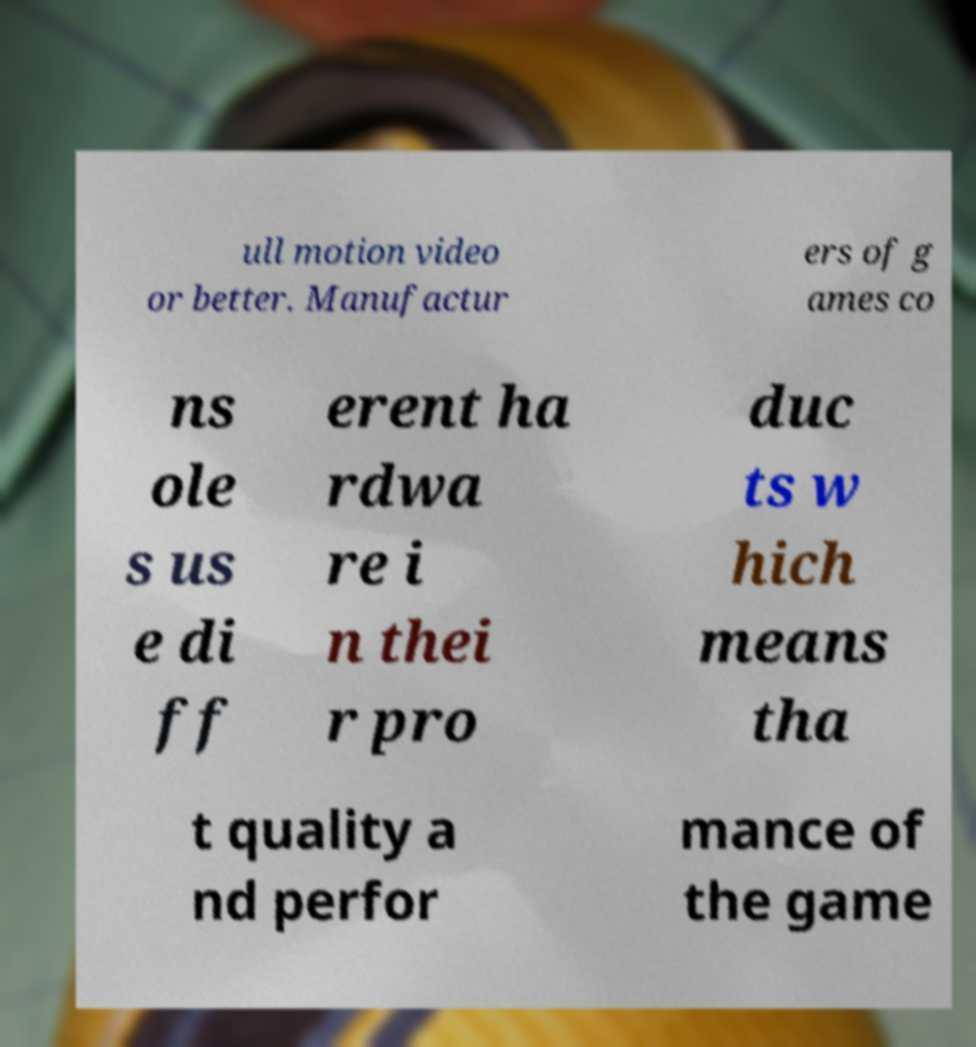I need the written content from this picture converted into text. Can you do that? ull motion video or better. Manufactur ers of g ames co ns ole s us e di ff erent ha rdwa re i n thei r pro duc ts w hich means tha t quality a nd perfor mance of the game 